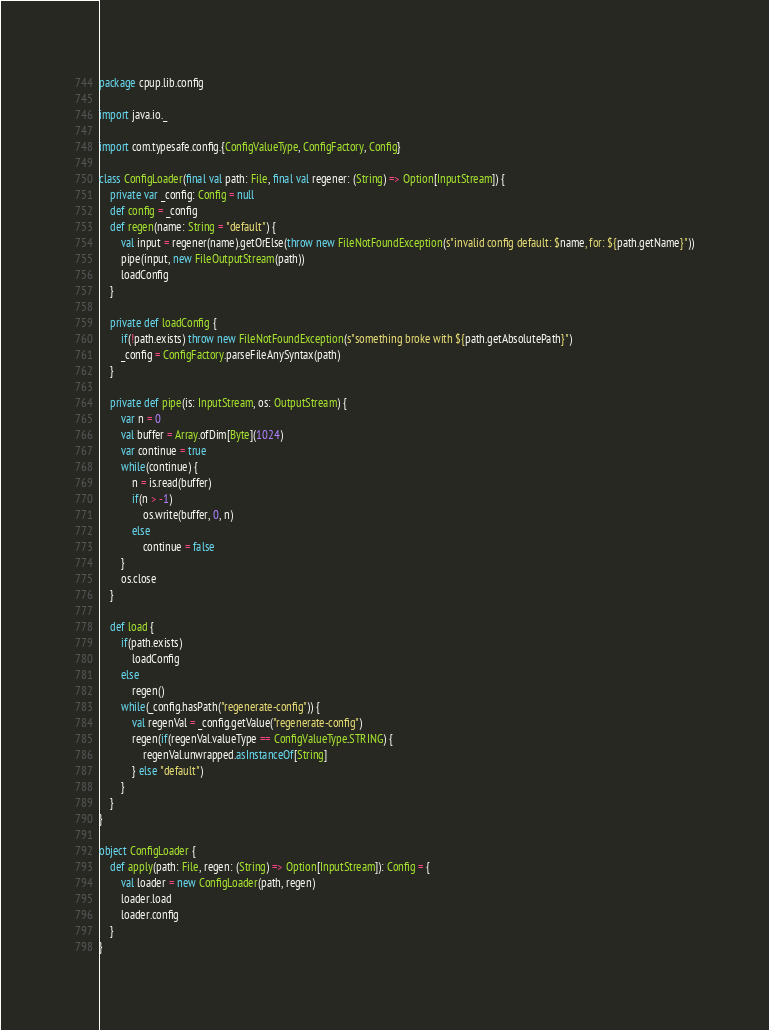<code> <loc_0><loc_0><loc_500><loc_500><_Scala_>package cpup.lib.config

import java.io._

import com.typesafe.config.{ConfigValueType, ConfigFactory, Config}

class ConfigLoader(final val path: File, final val regener: (String) => Option[InputStream]) {
	private var _config: Config = null
	def config = _config
	def regen(name: String = "default") {
		val input = regener(name).getOrElse(throw new FileNotFoundException(s"invalid config default: $name, for: ${path.getName}"))
		pipe(input, new FileOutputStream(path))
		loadConfig
	}

	private def loadConfig {
		if(!path.exists) throw new FileNotFoundException(s"something broke with ${path.getAbsolutePath}")
		_config = ConfigFactory.parseFileAnySyntax(path)
	}

	private def pipe(is: InputStream, os: OutputStream) {
		var n = 0
		val buffer = Array.ofDim[Byte](1024)
		var continue = true
		while(continue) {
			n = is.read(buffer)
			if(n > -1)
				os.write(buffer, 0, n)
			else
				continue = false
		}
		os.close
	}

	def load {
		if(path.exists)
			loadConfig
		else
			regen()
		while(_config.hasPath("regenerate-config")) {
			val regenVal = _config.getValue("regenerate-config")
			regen(if(regenVal.valueType == ConfigValueType.STRING) {
				regenVal.unwrapped.asInstanceOf[String]
			} else "default")
		}
	}
}

object ConfigLoader {
	def apply(path: File, regen: (String) => Option[InputStream]): Config = {
		val loader = new ConfigLoader(path, regen)
		loader.load
		loader.config
	}
}
</code> 